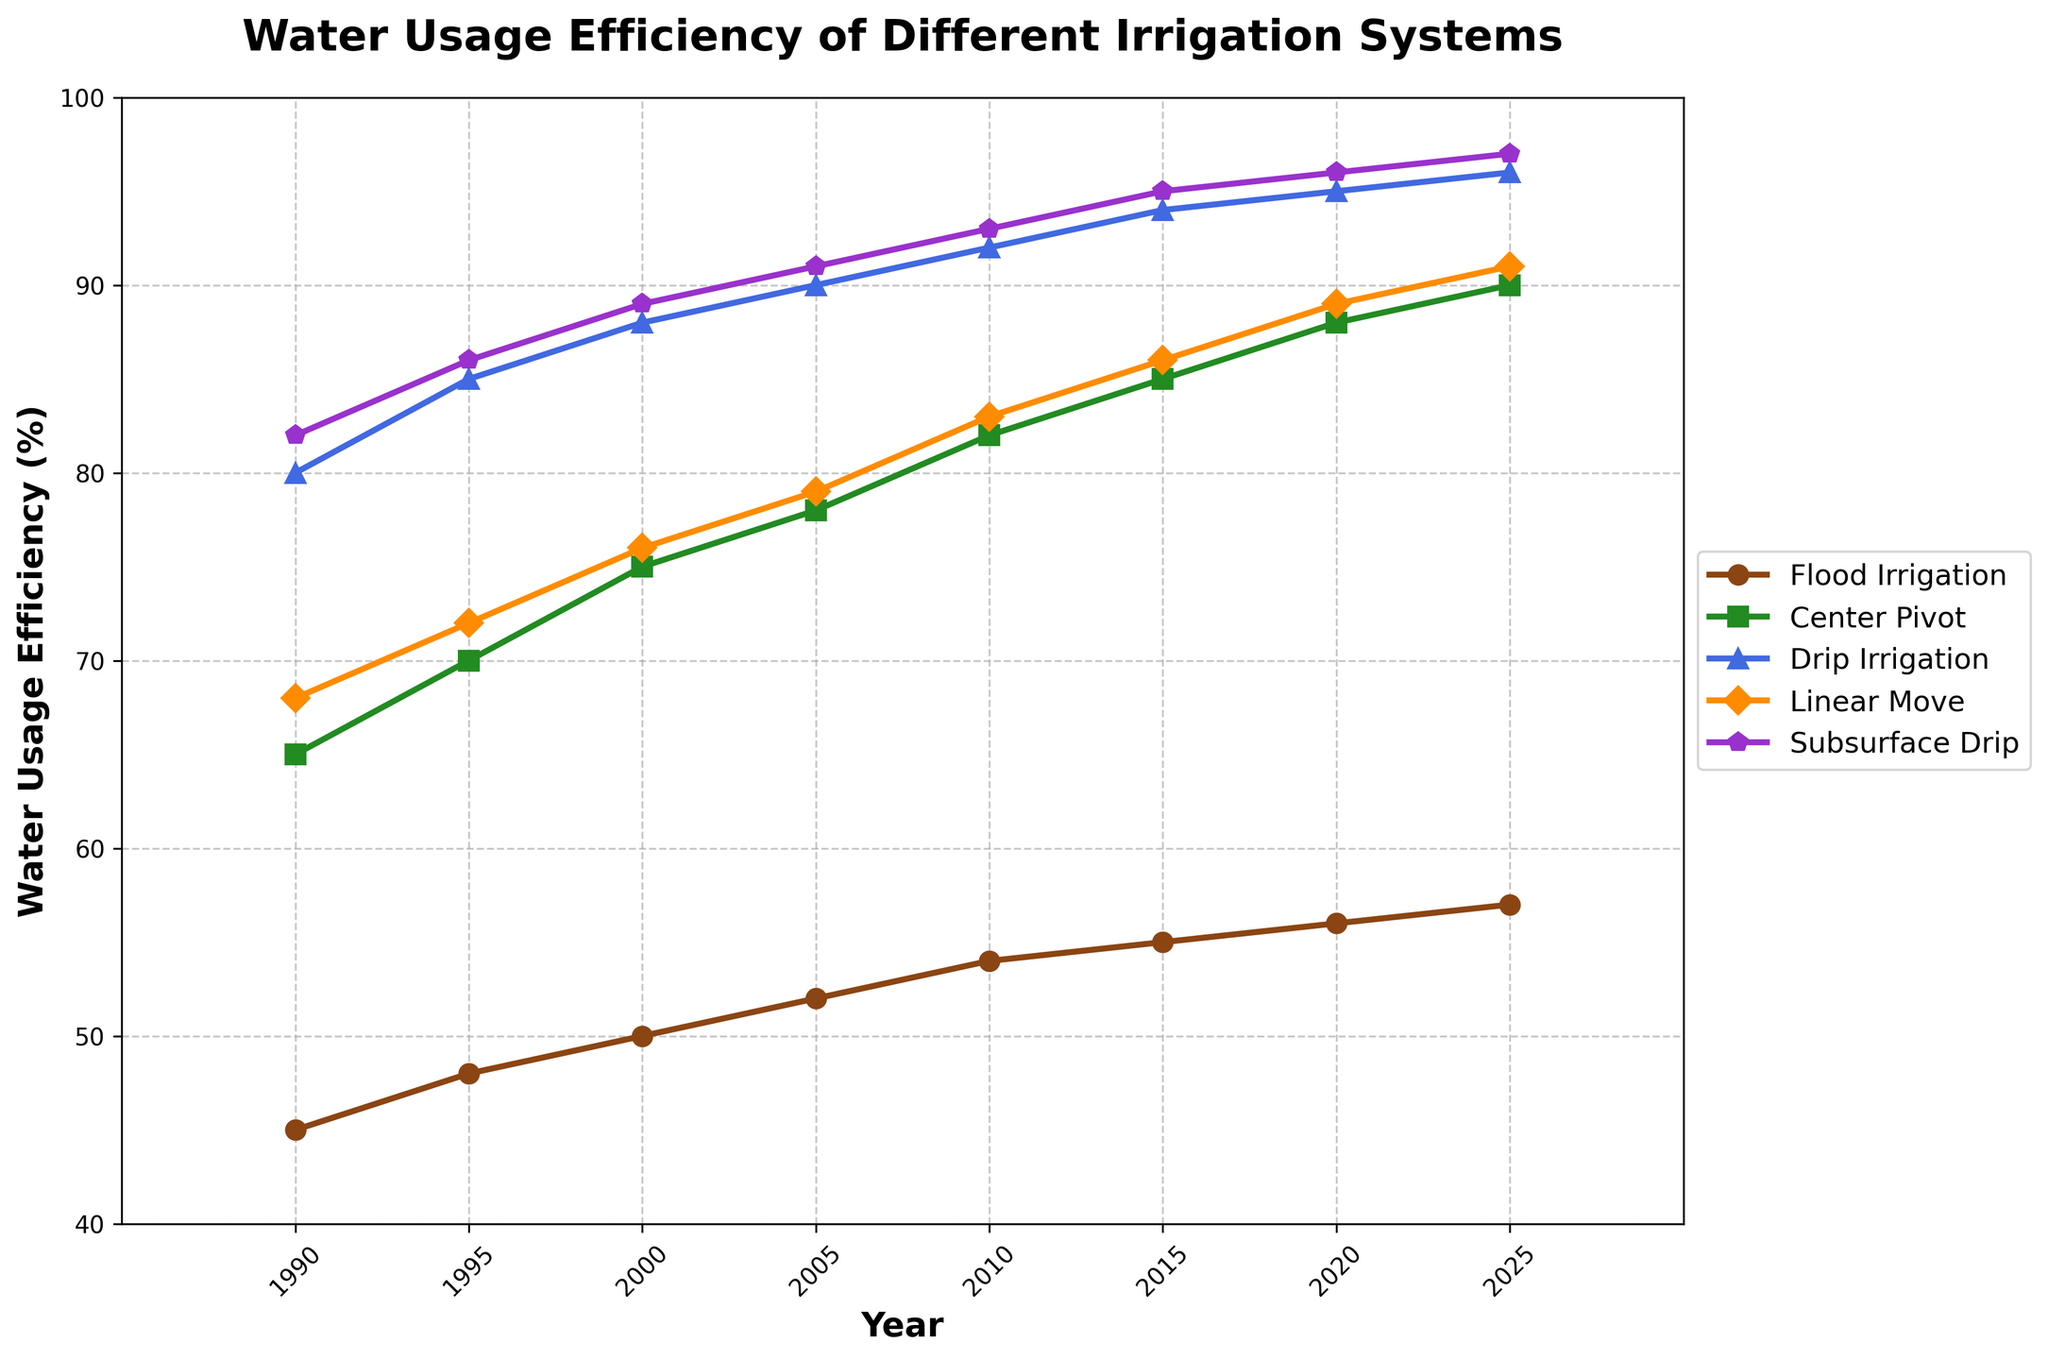Which irrigation system showed the highest water usage efficiency in 1990? Look at the 1990 value for each irrigation system. Subsurface Drip has the highest value of 82%.
Answer: Subsurface Drip How did the water usage efficiency of Center Pivot change from 1990 to 2020? Subtract the value in 1990 from the value in 2020 for Center Pivot: 88 - 65 = 23.
Answer: Increased by 23% Which irrigation system had the least improvement in water usage efficiency between 1990 and 2025? Calculate the difference between the 2025 and 1990 values for all systems and determine the smallest increase. Flood Irrigation improved from 45 to 57, an increase of 12, which is the smallest.
Answer: Flood Irrigation By how much did the water usage efficiency of Drip Irrigation increase from 2000 to 2025? Subtract the value in 2000 from the value in 2025 for Drip Irrigation: 96 - 88 = 8.
Answer: Increased by 8% Which two irrigation systems have the closest efficiency values in 2015? Compare the 2015 values of all irrigation systems to find the smallest difference between any two systems. Center Pivot and Linear Move have values of 85% and 86% respectively, with a difference of 1.
Answer: Center Pivot and Linear Move In which year do all irrigation systems show the highest collective efficiency? Find the year where the sum of all irrigation systems' efficiencies is the highest. Calculate the sums: 345 in 2025 is the highest.
Answer: 2025 Is there any year where Subsurface Drip is less efficient than Drip Irrigation? Compare the yearly values of Subsurface Drip and Drip Irrigation. In all years, Subsurface Drip has higher or equal efficiency compared to Drip Irrigation.
Answer: No What is the average efficiency of Linear Move between 1990 and 2025? Sum the values for Linear Move from 1990 to 2025 (68 + 72 + 76 + 79 + 83 + 86 + 89 + 91 = 644) and divide by the number of years (8). The average is 644/8 = 80.5.
Answer: 80.5 By how much did the water usage efficiency of Flood Irrigation increase between 1995 and 2005? Subtract the 1995 value of Flood Irrigation from the 2005 value: 52 - 48 = 4.
Answer: Increased by 4% 